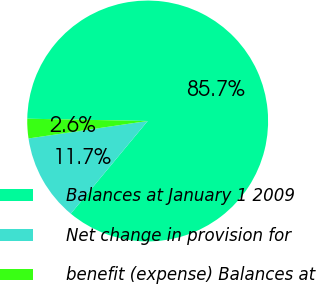Convert chart to OTSL. <chart><loc_0><loc_0><loc_500><loc_500><pie_chart><fcel>Balances at January 1 2009<fcel>Net change in provision for<fcel>benefit (expense) Balances at<nl><fcel>85.72%<fcel>11.66%<fcel>2.62%<nl></chart> 